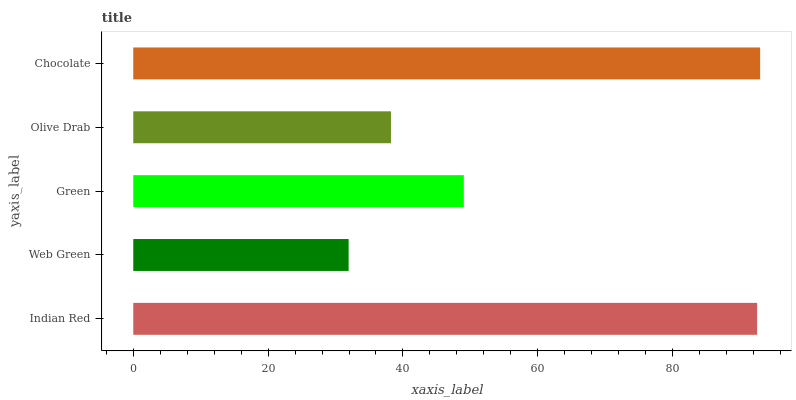Is Web Green the minimum?
Answer yes or no. Yes. Is Chocolate the maximum?
Answer yes or no. Yes. Is Green the minimum?
Answer yes or no. No. Is Green the maximum?
Answer yes or no. No. Is Green greater than Web Green?
Answer yes or no. Yes. Is Web Green less than Green?
Answer yes or no. Yes. Is Web Green greater than Green?
Answer yes or no. No. Is Green less than Web Green?
Answer yes or no. No. Is Green the high median?
Answer yes or no. Yes. Is Green the low median?
Answer yes or no. Yes. Is Olive Drab the high median?
Answer yes or no. No. Is Chocolate the low median?
Answer yes or no. No. 